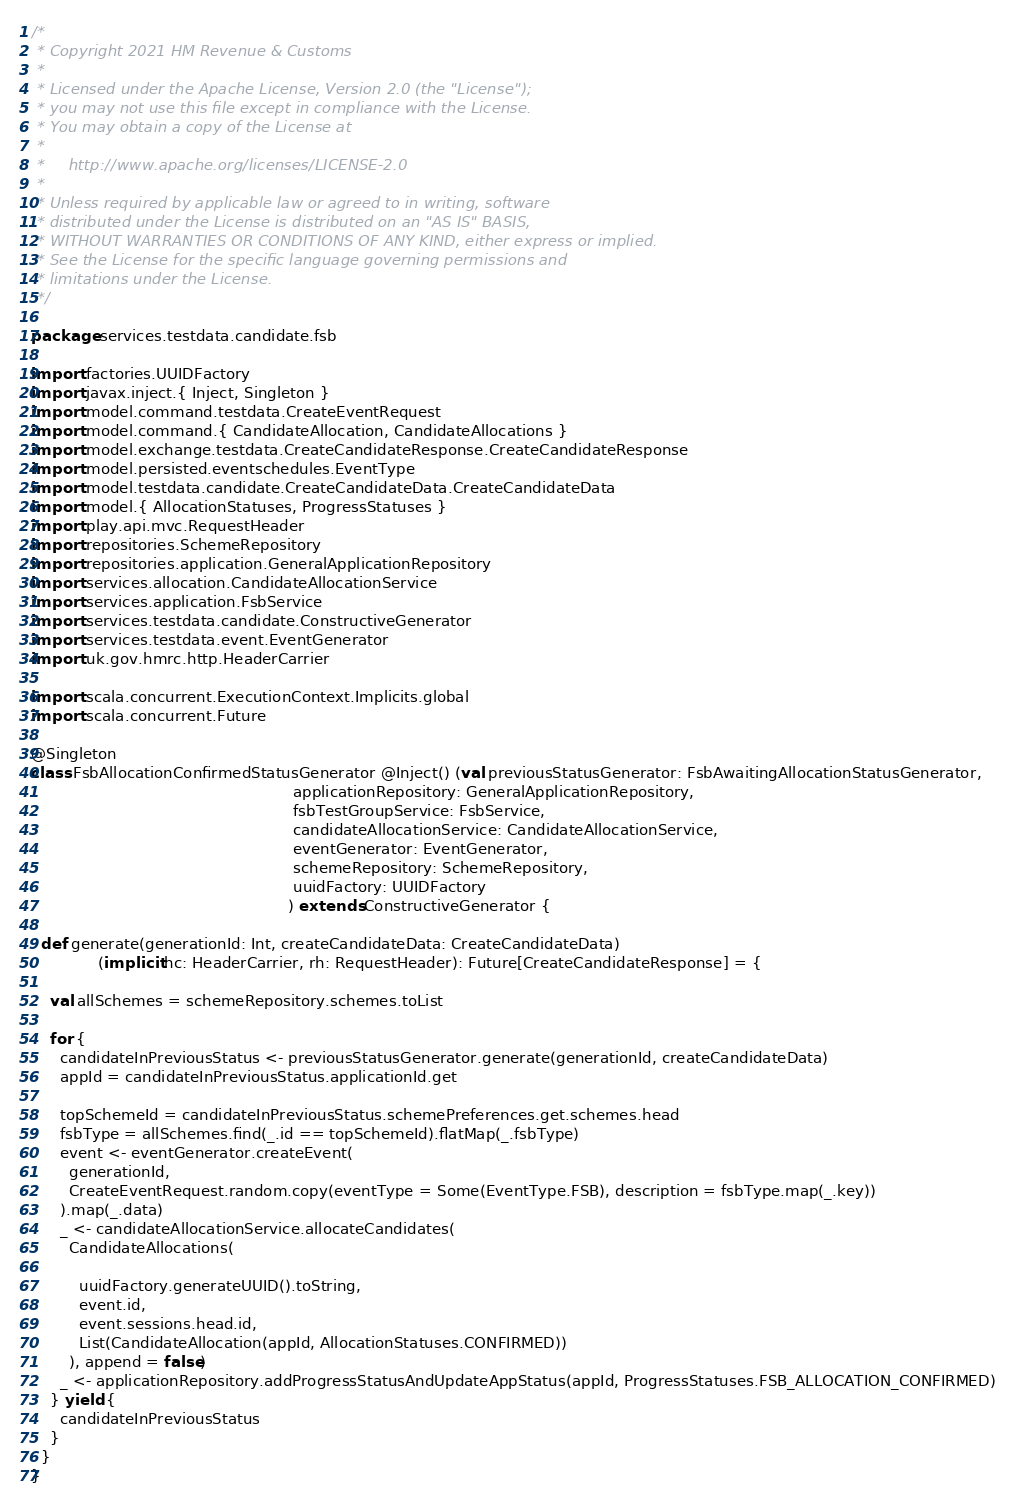Convert code to text. <code><loc_0><loc_0><loc_500><loc_500><_Scala_>/*
 * Copyright 2021 HM Revenue & Customs
 *
 * Licensed under the Apache License, Version 2.0 (the "License");
 * you may not use this file except in compliance with the License.
 * You may obtain a copy of the License at
 *
 *     http://www.apache.org/licenses/LICENSE-2.0
 *
 * Unless required by applicable law or agreed to in writing, software
 * distributed under the License is distributed on an "AS IS" BASIS,
 * WITHOUT WARRANTIES OR CONDITIONS OF ANY KIND, either express or implied.
 * See the License for the specific language governing permissions and
 * limitations under the License.
 */

package services.testdata.candidate.fsb

import factories.UUIDFactory
import javax.inject.{ Inject, Singleton }
import model.command.testdata.CreateEventRequest
import model.command.{ CandidateAllocation, CandidateAllocations }
import model.exchange.testdata.CreateCandidateResponse.CreateCandidateResponse
import model.persisted.eventschedules.EventType
import model.testdata.candidate.CreateCandidateData.CreateCandidateData
import model.{ AllocationStatuses, ProgressStatuses }
import play.api.mvc.RequestHeader
import repositories.SchemeRepository
import repositories.application.GeneralApplicationRepository
import services.allocation.CandidateAllocationService
import services.application.FsbService
import services.testdata.candidate.ConstructiveGenerator
import services.testdata.event.EventGenerator
import uk.gov.hmrc.http.HeaderCarrier

import scala.concurrent.ExecutionContext.Implicits.global
import scala.concurrent.Future

@Singleton
class FsbAllocationConfirmedStatusGenerator @Inject() (val previousStatusGenerator: FsbAwaitingAllocationStatusGenerator,
                                                       applicationRepository: GeneralApplicationRepository,
                                                       fsbTestGroupService: FsbService,
                                                       candidateAllocationService: CandidateAllocationService,
                                                       eventGenerator: EventGenerator,
                                                       schemeRepository: SchemeRepository,
                                                       uuidFactory: UUIDFactory
                                                      ) extends ConstructiveGenerator {

  def generate(generationId: Int, createCandidateData: CreateCandidateData)
              (implicit hc: HeaderCarrier, rh: RequestHeader): Future[CreateCandidateResponse] = {

    val allSchemes = schemeRepository.schemes.toList

    for {
      candidateInPreviousStatus <- previousStatusGenerator.generate(generationId, createCandidateData)
      appId = candidateInPreviousStatus.applicationId.get

      topSchemeId = candidateInPreviousStatus.schemePreferences.get.schemes.head
      fsbType = allSchemes.find(_.id == topSchemeId).flatMap(_.fsbType)
      event <- eventGenerator.createEvent(
        generationId,
        CreateEventRequest.random.copy(eventType = Some(EventType.FSB), description = fsbType.map(_.key))
      ).map(_.data)
      _ <- candidateAllocationService.allocateCandidates(
        CandidateAllocations(

          uuidFactory.generateUUID().toString,
          event.id,
          event.sessions.head.id,
          List(CandidateAllocation(appId, AllocationStatuses.CONFIRMED))
        ), append = false)
      _ <- applicationRepository.addProgressStatusAndUpdateAppStatus(appId, ProgressStatuses.FSB_ALLOCATION_CONFIRMED)
    } yield {
      candidateInPreviousStatus
    }
  }
}
</code> 